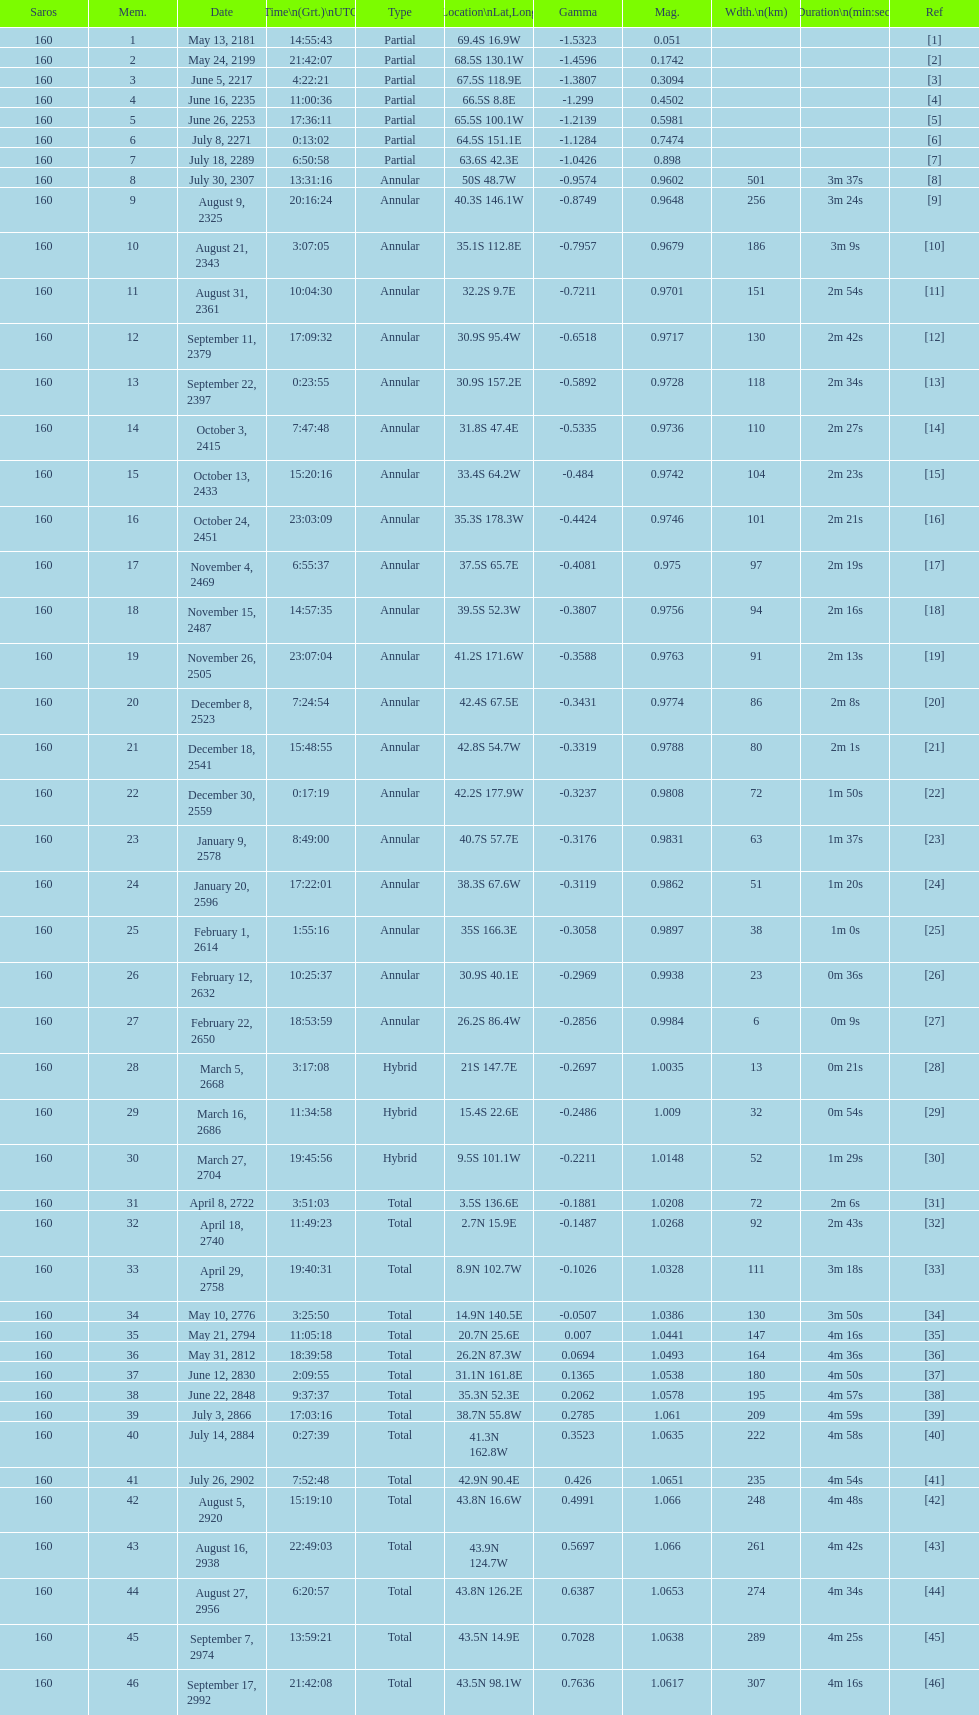Give me the full table as a dictionary. {'header': ['Saros', 'Mem.', 'Date', 'Time\\n(Grt.)\\nUTC', 'Type', 'Location\\nLat,Long', 'Gamma', 'Mag.', 'Wdth.\\n(km)', 'Duration\\n(min:sec)', 'Ref'], 'rows': [['160', '1', 'May 13, 2181', '14:55:43', 'Partial', '69.4S 16.9W', '-1.5323', '0.051', '', '', '[1]'], ['160', '2', 'May 24, 2199', '21:42:07', 'Partial', '68.5S 130.1W', '-1.4596', '0.1742', '', '', '[2]'], ['160', '3', 'June 5, 2217', '4:22:21', 'Partial', '67.5S 118.9E', '-1.3807', '0.3094', '', '', '[3]'], ['160', '4', 'June 16, 2235', '11:00:36', 'Partial', '66.5S 8.8E', '-1.299', '0.4502', '', '', '[4]'], ['160', '5', 'June 26, 2253', '17:36:11', 'Partial', '65.5S 100.1W', '-1.2139', '0.5981', '', '', '[5]'], ['160', '6', 'July 8, 2271', '0:13:02', 'Partial', '64.5S 151.1E', '-1.1284', '0.7474', '', '', '[6]'], ['160', '7', 'July 18, 2289', '6:50:58', 'Partial', '63.6S 42.3E', '-1.0426', '0.898', '', '', '[7]'], ['160', '8', 'July 30, 2307', '13:31:16', 'Annular', '50S 48.7W', '-0.9574', '0.9602', '501', '3m 37s', '[8]'], ['160', '9', 'August 9, 2325', '20:16:24', 'Annular', '40.3S 146.1W', '-0.8749', '0.9648', '256', '3m 24s', '[9]'], ['160', '10', 'August 21, 2343', '3:07:05', 'Annular', '35.1S 112.8E', '-0.7957', '0.9679', '186', '3m 9s', '[10]'], ['160', '11', 'August 31, 2361', '10:04:30', 'Annular', '32.2S 9.7E', '-0.7211', '0.9701', '151', '2m 54s', '[11]'], ['160', '12', 'September 11, 2379', '17:09:32', 'Annular', '30.9S 95.4W', '-0.6518', '0.9717', '130', '2m 42s', '[12]'], ['160', '13', 'September 22, 2397', '0:23:55', 'Annular', '30.9S 157.2E', '-0.5892', '0.9728', '118', '2m 34s', '[13]'], ['160', '14', 'October 3, 2415', '7:47:48', 'Annular', '31.8S 47.4E', '-0.5335', '0.9736', '110', '2m 27s', '[14]'], ['160', '15', 'October 13, 2433', '15:20:16', 'Annular', '33.4S 64.2W', '-0.484', '0.9742', '104', '2m 23s', '[15]'], ['160', '16', 'October 24, 2451', '23:03:09', 'Annular', '35.3S 178.3W', '-0.4424', '0.9746', '101', '2m 21s', '[16]'], ['160', '17', 'November 4, 2469', '6:55:37', 'Annular', '37.5S 65.7E', '-0.4081', '0.975', '97', '2m 19s', '[17]'], ['160', '18', 'November 15, 2487', '14:57:35', 'Annular', '39.5S 52.3W', '-0.3807', '0.9756', '94', '2m 16s', '[18]'], ['160', '19', 'November 26, 2505', '23:07:04', 'Annular', '41.2S 171.6W', '-0.3588', '0.9763', '91', '2m 13s', '[19]'], ['160', '20', 'December 8, 2523', '7:24:54', 'Annular', '42.4S 67.5E', '-0.3431', '0.9774', '86', '2m 8s', '[20]'], ['160', '21', 'December 18, 2541', '15:48:55', 'Annular', '42.8S 54.7W', '-0.3319', '0.9788', '80', '2m 1s', '[21]'], ['160', '22', 'December 30, 2559', '0:17:19', 'Annular', '42.2S 177.9W', '-0.3237', '0.9808', '72', '1m 50s', '[22]'], ['160', '23', 'January 9, 2578', '8:49:00', 'Annular', '40.7S 57.7E', '-0.3176', '0.9831', '63', '1m 37s', '[23]'], ['160', '24', 'January 20, 2596', '17:22:01', 'Annular', '38.3S 67.6W', '-0.3119', '0.9862', '51', '1m 20s', '[24]'], ['160', '25', 'February 1, 2614', '1:55:16', 'Annular', '35S 166.3E', '-0.3058', '0.9897', '38', '1m 0s', '[25]'], ['160', '26', 'February 12, 2632', '10:25:37', 'Annular', '30.9S 40.1E', '-0.2969', '0.9938', '23', '0m 36s', '[26]'], ['160', '27', 'February 22, 2650', '18:53:59', 'Annular', '26.2S 86.4W', '-0.2856', '0.9984', '6', '0m 9s', '[27]'], ['160', '28', 'March 5, 2668', '3:17:08', 'Hybrid', '21S 147.7E', '-0.2697', '1.0035', '13', '0m 21s', '[28]'], ['160', '29', 'March 16, 2686', '11:34:58', 'Hybrid', '15.4S 22.6E', '-0.2486', '1.009', '32', '0m 54s', '[29]'], ['160', '30', 'March 27, 2704', '19:45:56', 'Hybrid', '9.5S 101.1W', '-0.2211', '1.0148', '52', '1m 29s', '[30]'], ['160', '31', 'April 8, 2722', '3:51:03', 'Total', '3.5S 136.6E', '-0.1881', '1.0208', '72', '2m 6s', '[31]'], ['160', '32', 'April 18, 2740', '11:49:23', 'Total', '2.7N 15.9E', '-0.1487', '1.0268', '92', '2m 43s', '[32]'], ['160', '33', 'April 29, 2758', '19:40:31', 'Total', '8.9N 102.7W', '-0.1026', '1.0328', '111', '3m 18s', '[33]'], ['160', '34', 'May 10, 2776', '3:25:50', 'Total', '14.9N 140.5E', '-0.0507', '1.0386', '130', '3m 50s', '[34]'], ['160', '35', 'May 21, 2794', '11:05:18', 'Total', '20.7N 25.6E', '0.007', '1.0441', '147', '4m 16s', '[35]'], ['160', '36', 'May 31, 2812', '18:39:58', 'Total', '26.2N 87.3W', '0.0694', '1.0493', '164', '4m 36s', '[36]'], ['160', '37', 'June 12, 2830', '2:09:55', 'Total', '31.1N 161.8E', '0.1365', '1.0538', '180', '4m 50s', '[37]'], ['160', '38', 'June 22, 2848', '9:37:37', 'Total', '35.3N 52.3E', '0.2062', '1.0578', '195', '4m 57s', '[38]'], ['160', '39', 'July 3, 2866', '17:03:16', 'Total', '38.7N 55.8W', '0.2785', '1.061', '209', '4m 59s', '[39]'], ['160', '40', 'July 14, 2884', '0:27:39', 'Total', '41.3N 162.8W', '0.3523', '1.0635', '222', '4m 58s', '[40]'], ['160', '41', 'July 26, 2902', '7:52:48', 'Total', '42.9N 90.4E', '0.426', '1.0651', '235', '4m 54s', '[41]'], ['160', '42', 'August 5, 2920', '15:19:10', 'Total', '43.8N 16.6W', '0.4991', '1.066', '248', '4m 48s', '[42]'], ['160', '43', 'August 16, 2938', '22:49:03', 'Total', '43.9N 124.7W', '0.5697', '1.066', '261', '4m 42s', '[43]'], ['160', '44', 'August 27, 2956', '6:20:57', 'Total', '43.8N 126.2E', '0.6387', '1.0653', '274', '4m 34s', '[44]'], ['160', '45', 'September 7, 2974', '13:59:21', 'Total', '43.5N 14.9E', '0.7028', '1.0638', '289', '4m 25s', '[45]'], ['160', '46', 'September 17, 2992', '21:42:08', 'Total', '43.5N 98.1W', '0.7636', '1.0617', '307', '4m 16s', '[46]']]} How many total events will occur in all? 46. 